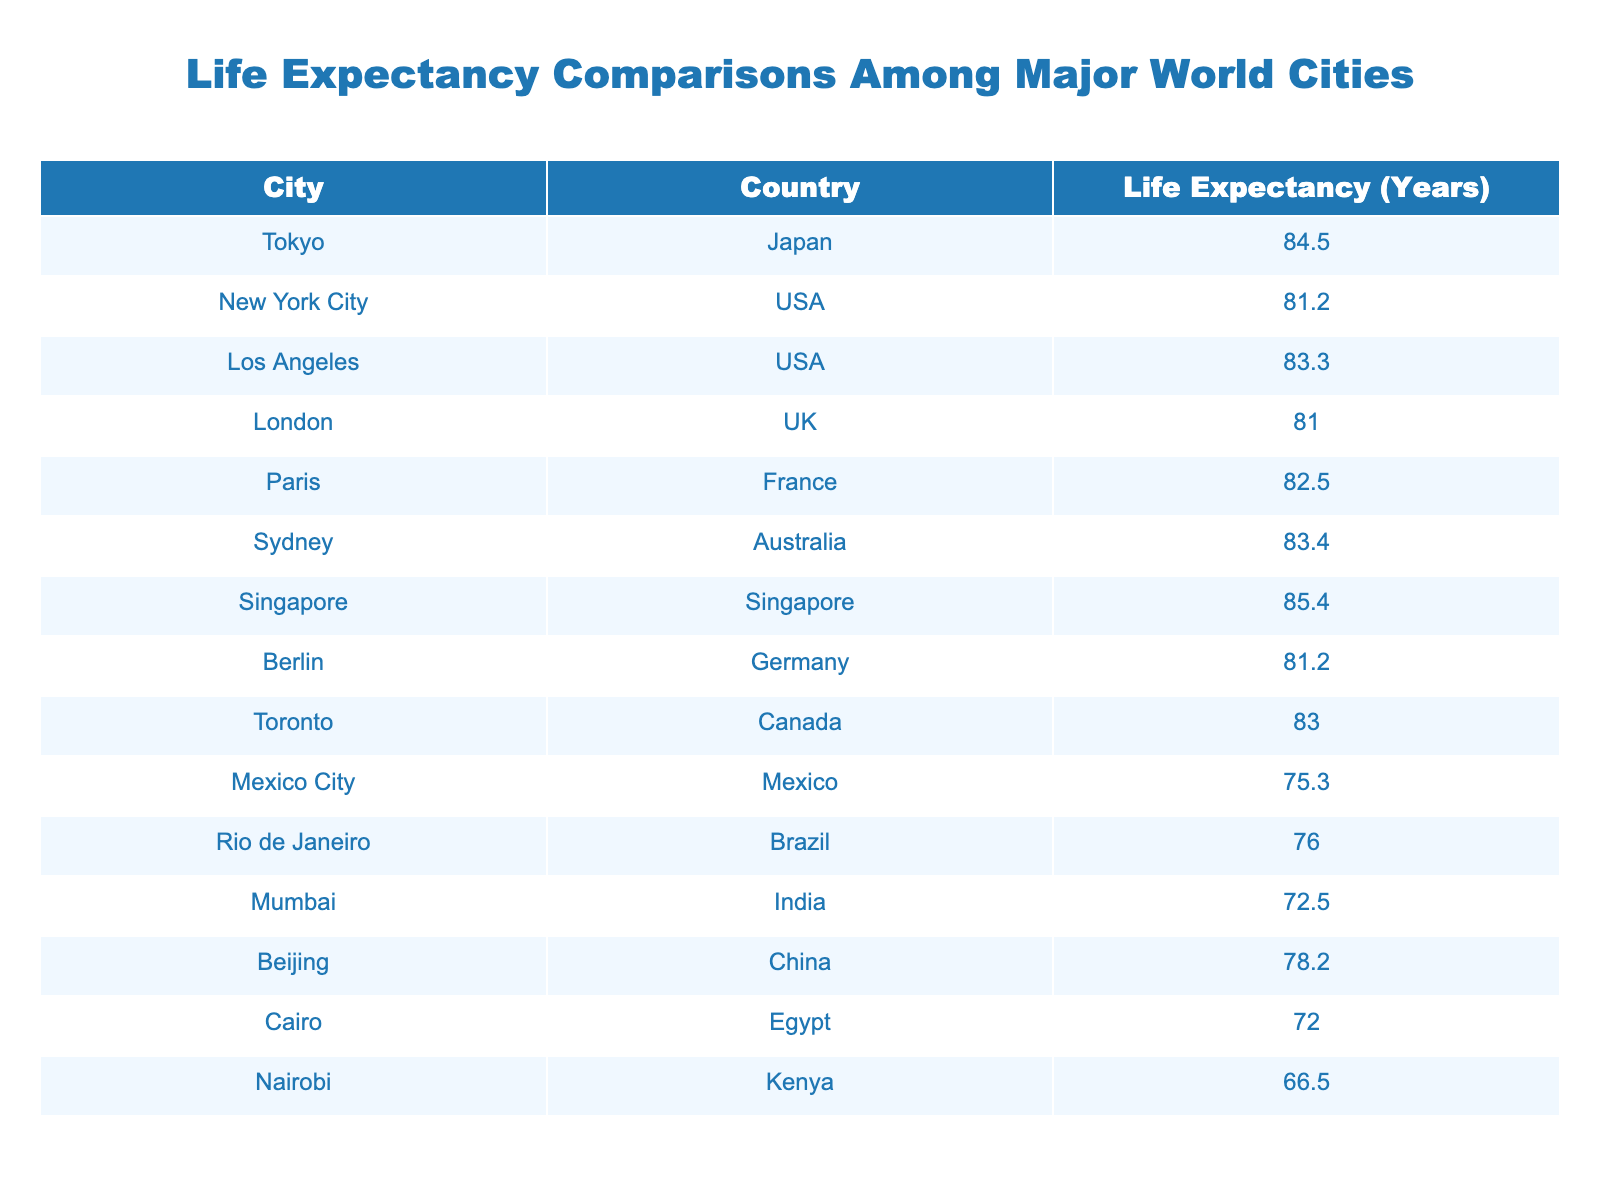What is the highest life expectancy among the cities listed? Looking at the 'Life Expectancy (Years)' column, the highest value is 85.4, which corresponds to Singapore.
Answer: 85.4 Which city has a life expectancy closest to the average of all listed cities? To find the average life expectancy, we add all the values: 84.5 + 81.2 + 83.3 + 81.0 + 82.5 + 83.4 + 85.4 + 81.2 + 83.0 + 75.3 + 76.0 + 72.5 + 78.2 + 72.0 + 66.5 = 1247.8. Then divide by the number of cities, which is 15: 1247.8 / 15 = 83.19. The value closest to this average is 83.0, which corresponds to Toronto.
Answer: Toronto Is the life expectancy in Nairobi higher than that in Cairo? The life expectancy in Nairobi is 66.5 years, and in Cairo, it is 72.0 years. Since 66.5 is not higher than 72.0, the answer is no.
Answer: No What is the difference in life expectancy between Tokyo and Los Angeles? The life expectancies are 84.5 years for Tokyo and 83.3 years for Los Angeles. The difference is 84.5 - 83.3 = 1.2 years.
Answer: 1.2 How many cities have a life expectancy below 80 years? Looking through the 'Life Expectancy (Years)' column, the values below 80 are 75.3 (Mexico City), 76.0 (Rio de Janeiro), 72.5 (Mumbai), 78.2 (Beijing), 72.0 (Cairo), and 66.5 (Nairobi), totaling 6 cities.
Answer: 6 Which countries have cities with life expectancies above 84 years? Checking each city, only Singapore (85.4 years) and Tokyo (84.5 years) have life expectancies above 84 years, so the countries are Singapore and Japan.
Answer: Singapore and Japan 